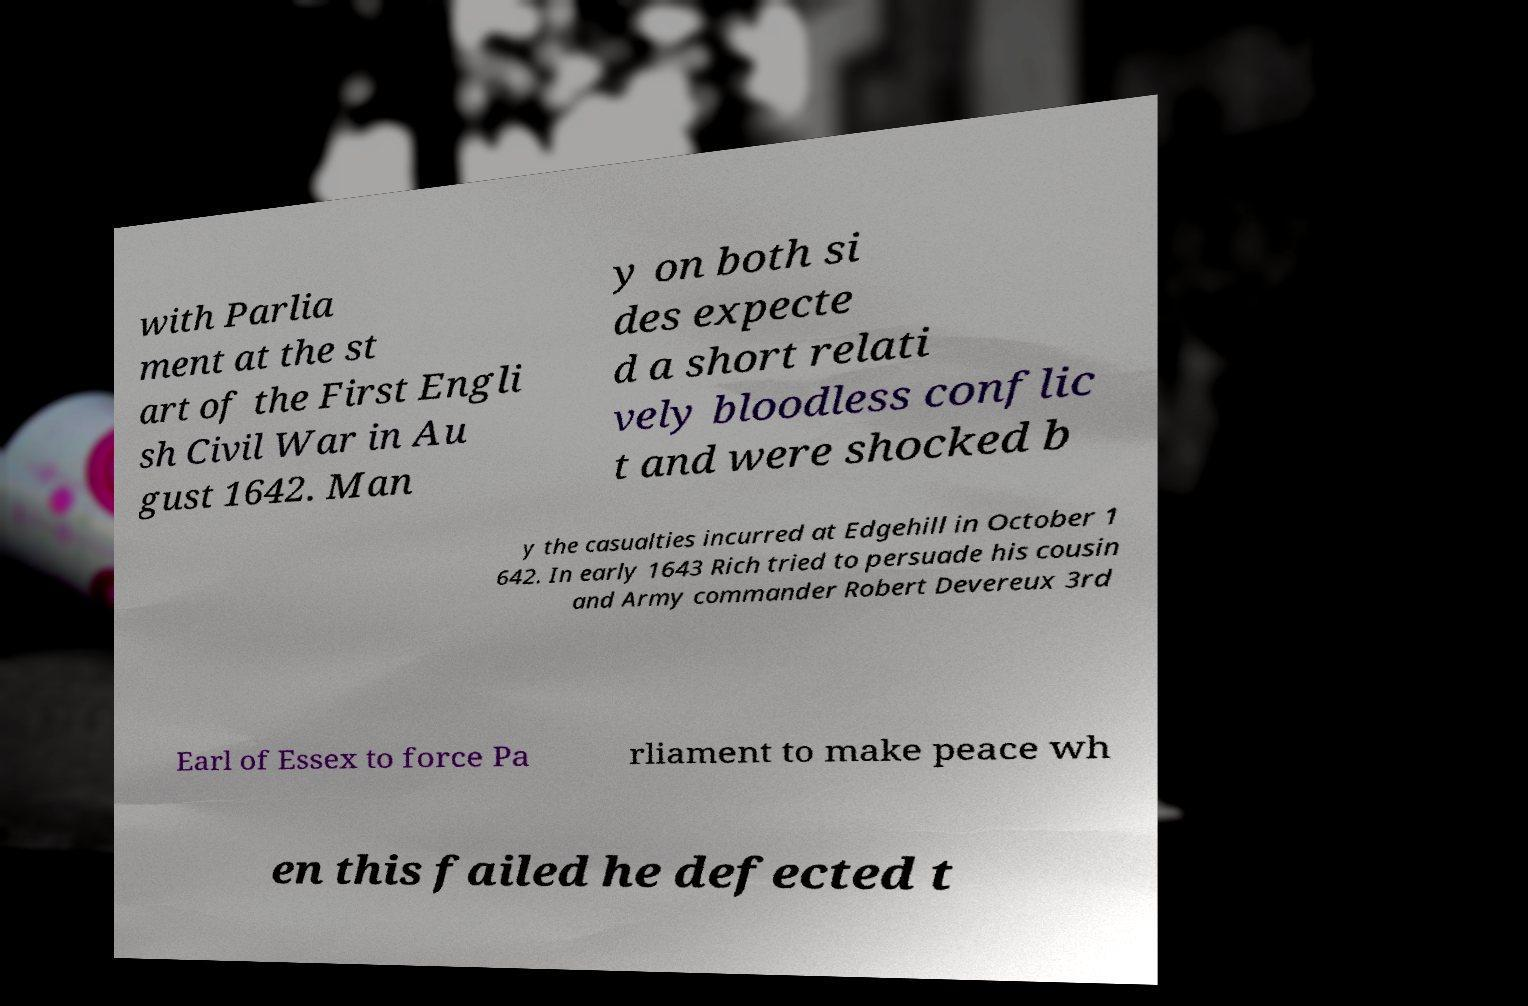Could you assist in decoding the text presented in this image and type it out clearly? with Parlia ment at the st art of the First Engli sh Civil War in Au gust 1642. Man y on both si des expecte d a short relati vely bloodless conflic t and were shocked b y the casualties incurred at Edgehill in October 1 642. In early 1643 Rich tried to persuade his cousin and Army commander Robert Devereux 3rd Earl of Essex to force Pa rliament to make peace wh en this failed he defected t 